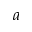Convert formula to latex. <formula><loc_0><loc_0><loc_500><loc_500>a</formula> 